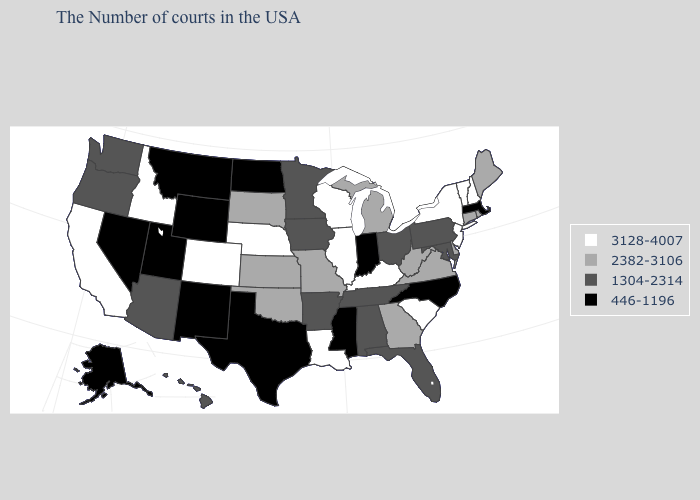What is the value of Vermont?
Short answer required. 3128-4007. Does Michigan have a higher value than Texas?
Quick response, please. Yes. Is the legend a continuous bar?
Answer briefly. No. Among the states that border Alabama , which have the lowest value?
Give a very brief answer. Mississippi. What is the lowest value in states that border Connecticut?
Answer briefly. 446-1196. Which states hav the highest value in the Northeast?
Keep it brief. New Hampshire, Vermont, New York, New Jersey. What is the value of Missouri?
Be succinct. 2382-3106. Is the legend a continuous bar?
Short answer required. No. Does Virginia have the highest value in the USA?
Answer briefly. No. Name the states that have a value in the range 2382-3106?
Be succinct. Maine, Rhode Island, Connecticut, Delaware, Virginia, West Virginia, Georgia, Michigan, Missouri, Kansas, Oklahoma, South Dakota. What is the highest value in the South ?
Keep it brief. 3128-4007. Does Rhode Island have the highest value in the Northeast?
Be succinct. No. Does Washington have a lower value than Wyoming?
Concise answer only. No. What is the value of Vermont?
Answer briefly. 3128-4007. 